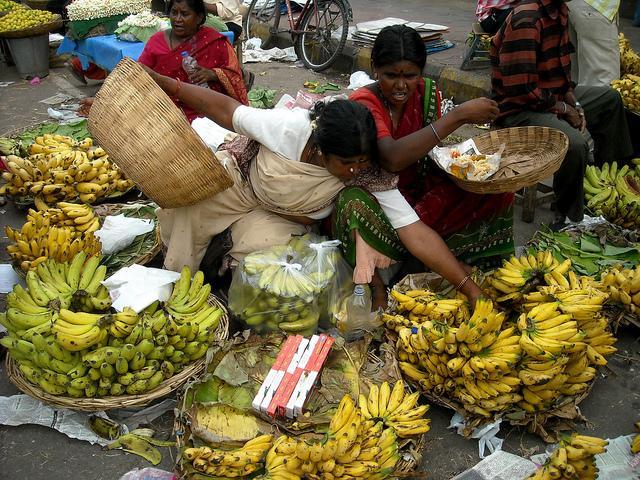What will the people place the fruit in?
Write a very short answer. Baskets. Is this person selling items in a grocery store?
Give a very brief answer. No. Is this an outdoor or indoor scene?
Answer briefly. Outdoor. What type of fruit is this?
Write a very short answer. Bananas. 